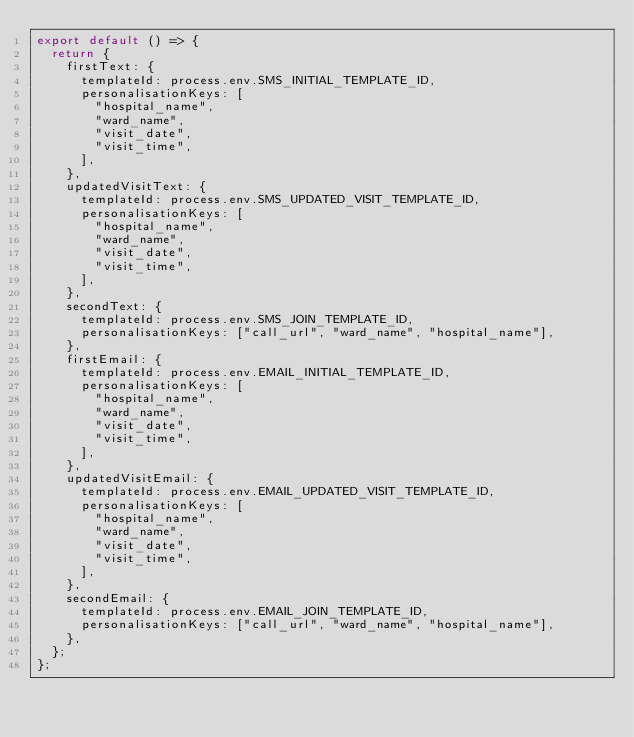Convert code to text. <code><loc_0><loc_0><loc_500><loc_500><_JavaScript_>export default () => {
  return {
    firstText: {
      templateId: process.env.SMS_INITIAL_TEMPLATE_ID,
      personalisationKeys: [
        "hospital_name",
        "ward_name",
        "visit_date",
        "visit_time",
      ],
    },
    updatedVisitText: {
      templateId: process.env.SMS_UPDATED_VISIT_TEMPLATE_ID,
      personalisationKeys: [
        "hospital_name",
        "ward_name",
        "visit_date",
        "visit_time",
      ],
    },
    secondText: {
      templateId: process.env.SMS_JOIN_TEMPLATE_ID,
      personalisationKeys: ["call_url", "ward_name", "hospital_name"],
    },
    firstEmail: {
      templateId: process.env.EMAIL_INITIAL_TEMPLATE_ID,
      personalisationKeys: [
        "hospital_name",
        "ward_name",
        "visit_date",
        "visit_time",
      ],
    },
    updatedVisitEmail: {
      templateId: process.env.EMAIL_UPDATED_VISIT_TEMPLATE_ID,
      personalisationKeys: [
        "hospital_name",
        "ward_name",
        "visit_date",
        "visit_time",
      ],
    },
    secondEmail: {
      templateId: process.env.EMAIL_JOIN_TEMPLATE_ID,
      personalisationKeys: ["call_url", "ward_name", "hospital_name"],
    },
  };
};
</code> 